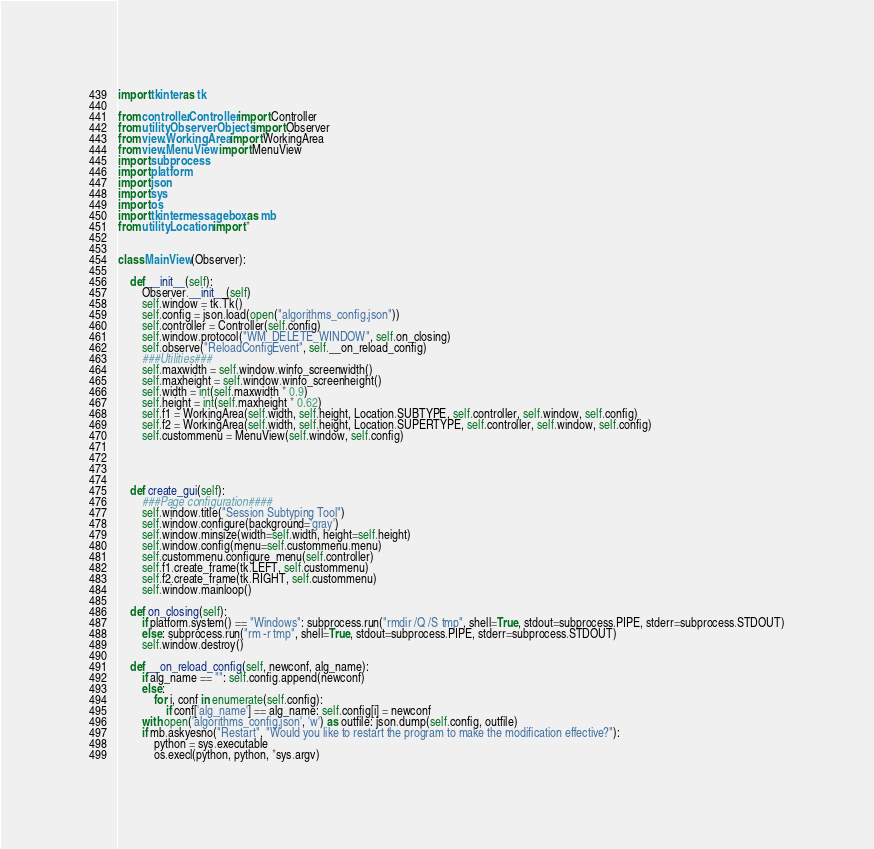<code> <loc_0><loc_0><loc_500><loc_500><_Python_>import tkinter as tk

from controller.Controller import Controller
from utility.ObserverObjects import Observer
from view.WorkingArea import WorkingArea
from view.MenuView import MenuView
import subprocess
import platform
import json
import sys
import os
import tkinter.messagebox as mb
from utility.Location import *


class MainView(Observer):

    def __init__(self):
        Observer.__init__(self)
        self.window = tk.Tk()
        self.config = json.load(open("algorithms_config.json"))
        self.controller = Controller(self.config)
        self.window.protocol("WM_DELETE_WINDOW", self.on_closing)
        self.observe("ReloadConfigEvent", self.__on_reload_config)
        ###Utilities###
        self.maxwidth = self.window.winfo_screenwidth()
        self.maxheight = self.window.winfo_screenheight()
        self.width = int(self.maxwidth * 0.9)
        self.height = int(self.maxheight * 0.62)
        self.f1 = WorkingArea(self.width, self.height, Location.SUBTYPE, self.controller, self.window, self.config)
        self.f2 = WorkingArea(self.width, self.height, Location.SUPERTYPE, self.controller, self.window, self.config)
        self.custommenu = MenuView(self.window, self.config)




    def create_gui(self):
        ###Page configuration####
        self.window.title("Session Subtyping Tool")
        self.window.configure(background='gray')
        self.window.minsize(width=self.width, height=self.height)
        self.window.config(menu=self.custommenu.menu)
        self.custommenu.configure_menu(self.controller)
        self.f1.create_frame(tk.LEFT, self.custommenu)
        self.f2.create_frame(tk.RIGHT, self.custommenu)
        self.window.mainloop()

    def on_closing(self):
        if platform.system() == "Windows": subprocess.run("rmdir /Q /S tmp", shell=True, stdout=subprocess.PIPE, stderr=subprocess.STDOUT)
        else: subprocess.run("rm -r tmp", shell=True, stdout=subprocess.PIPE, stderr=subprocess.STDOUT)
        self.window.destroy()

    def __on_reload_config(self, newconf, alg_name):
        if alg_name == "": self.config.append(newconf)
        else:
            for i, conf in enumerate(self.config):
                if conf['alg_name'] == alg_name: self.config[i] = newconf
        with open('algorithms_config.json', 'w') as outfile: json.dump(self.config, outfile)
        if mb.askyesno("Restart", "Would you like to restart the program to make the modification effective?"):
            python = sys.executable
            os.execl(python, python, *sys.argv)



</code> 